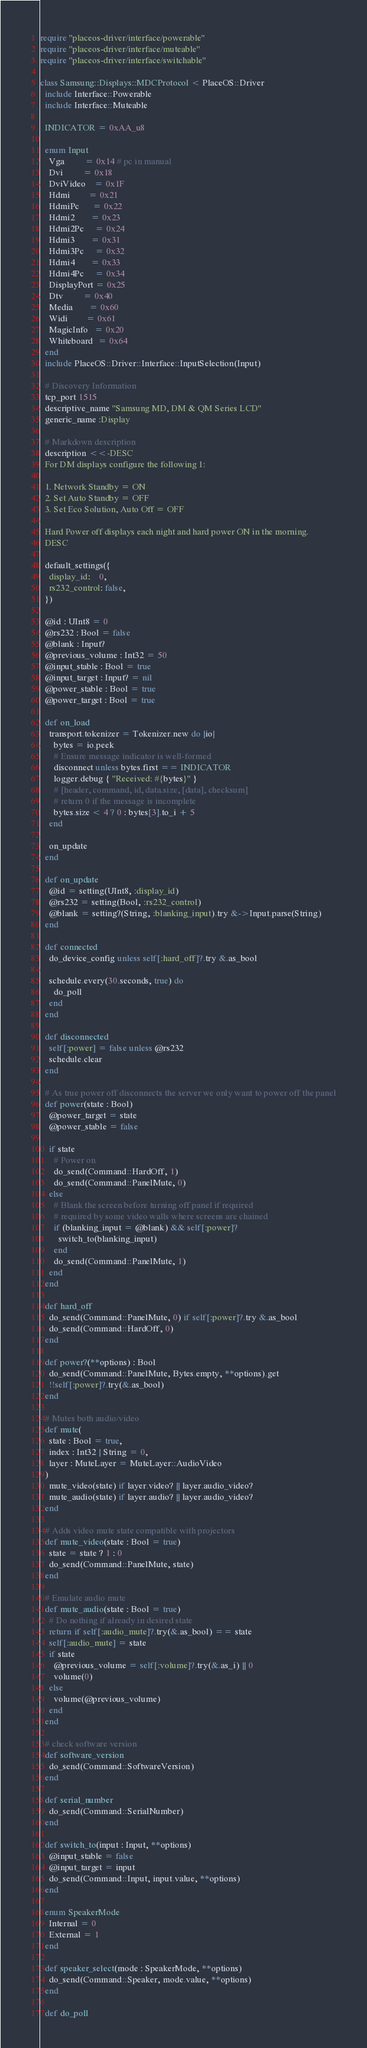Convert code to text. <code><loc_0><loc_0><loc_500><loc_500><_Crystal_>require "placeos-driver/interface/powerable"
require "placeos-driver/interface/muteable"
require "placeos-driver/interface/switchable"

class Samsung::Displays::MDCProtocol < PlaceOS::Driver
  include Interface::Powerable
  include Interface::Muteable

  INDICATOR = 0xAA_u8

  enum Input
    Vga         = 0x14 # pc in manual
    Dvi         = 0x18
    DviVideo    = 0x1F
    Hdmi        = 0x21
    HdmiPc      = 0x22
    Hdmi2       = 0x23
    Hdmi2Pc     = 0x24
    Hdmi3       = 0x31
    Hdmi3Pc     = 0x32
    Hdmi4       = 0x33
    Hdmi4Pc     = 0x34
    DisplayPort = 0x25
    Dtv         = 0x40
    Media       = 0x60
    Widi        = 0x61
    MagicInfo   = 0x20
    Whiteboard  = 0x64
  end
  include PlaceOS::Driver::Interface::InputSelection(Input)

  # Discovery Information
  tcp_port 1515
  descriptive_name "Samsung MD, DM & QM Series LCD"
  generic_name :Display

  # Markdown description
  description <<-DESC
  For DM displays configure the following 1:

  1. Network Standby = ON
  2. Set Auto Standby = OFF
  3. Set Eco Solution, Auto Off = OFF

  Hard Power off displays each night and hard power ON in the morning.
  DESC

  default_settings({
    display_id:    0,
    rs232_control: false,
  })

  @id : UInt8 = 0
  @rs232 : Bool = false
  @blank : Input?
  @previous_volume : Int32 = 50
  @input_stable : Bool = true
  @input_target : Input? = nil
  @power_stable : Bool = true
  @power_target : Bool = true

  def on_load
    transport.tokenizer = Tokenizer.new do |io|
      bytes = io.peek
      # Ensure message indicator is well-formed
      disconnect unless bytes.first == INDICATOR
      logger.debug { "Received: #{bytes}" }
      # [header, command, id, data.size, [data], checksum]
      # return 0 if the message is incomplete
      bytes.size < 4 ? 0 : bytes[3].to_i + 5
    end

    on_update
  end

  def on_update
    @id = setting(UInt8, :display_id)
    @rs232 = setting(Bool, :rs232_control)
    @blank = setting?(String, :blanking_input).try &->Input.parse(String)
  end

  def connected
    do_device_config unless self[:hard_off]?.try &.as_bool

    schedule.every(30.seconds, true) do
      do_poll
    end
  end

  def disconnected
    self[:power] = false unless @rs232
    schedule.clear
  end

  # As true power off disconnects the server we only want to power off the panel
  def power(state : Bool)
    @power_target = state
    @power_stable = false

    if state
      # Power on
      do_send(Command::HardOff, 1)
      do_send(Command::PanelMute, 0)
    else
      # Blank the screen before turning off panel if required
      # required by some video walls where screens are chained
      if (blanking_input = @blank) && self[:power]?
        switch_to(blanking_input)
      end
      do_send(Command::PanelMute, 1)
    end
  end

  def hard_off
    do_send(Command::PanelMute, 0) if self[:power]?.try &.as_bool
    do_send(Command::HardOff, 0)
  end

  def power?(**options) : Bool
    do_send(Command::PanelMute, Bytes.empty, **options).get
    !!self[:power]?.try(&.as_bool)
  end

  # Mutes both audio/video
  def mute(
    state : Bool = true,
    index : Int32 | String = 0,
    layer : MuteLayer = MuteLayer::AudioVideo
  )
    mute_video(state) if layer.video? || layer.audio_video?
    mute_audio(state) if layer.audio? || layer.audio_video?
  end

  # Adds video mute state compatible with projectors
  def mute_video(state : Bool = true)
    state = state ? 1 : 0
    do_send(Command::PanelMute, state)
  end

  # Emulate audio mute
  def mute_audio(state : Bool = true)
    # Do nothing if already in desired state
    return if self[:audio_mute]?.try(&.as_bool) == state
    self[:audio_mute] = state
    if state
      @previous_volume = self[:volume]?.try(&.as_i) || 0
      volume(0)
    else
      volume(@previous_volume)
    end
  end

  # check software version
  def software_version
    do_send(Command::SoftwareVersion)
  end

  def serial_number
    do_send(Command::SerialNumber)
  end

  def switch_to(input : Input, **options)
    @input_stable = false
    @input_target = input
    do_send(Command::Input, input.value, **options)
  end

  enum SpeakerMode
    Internal = 0
    External = 1
  end

  def speaker_select(mode : SpeakerMode, **options)
    do_send(Command::Speaker, mode.value, **options)
  end

  def do_poll</code> 